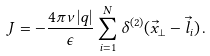Convert formula to latex. <formula><loc_0><loc_0><loc_500><loc_500>J = - \frac { 4 \pi \nu | q | } { \epsilon } \sum _ { i = 1 } ^ { N } \delta ^ { ( 2 ) } ( \vec { x } _ { \bot } - \vec { l } _ { i } ) \, .</formula> 